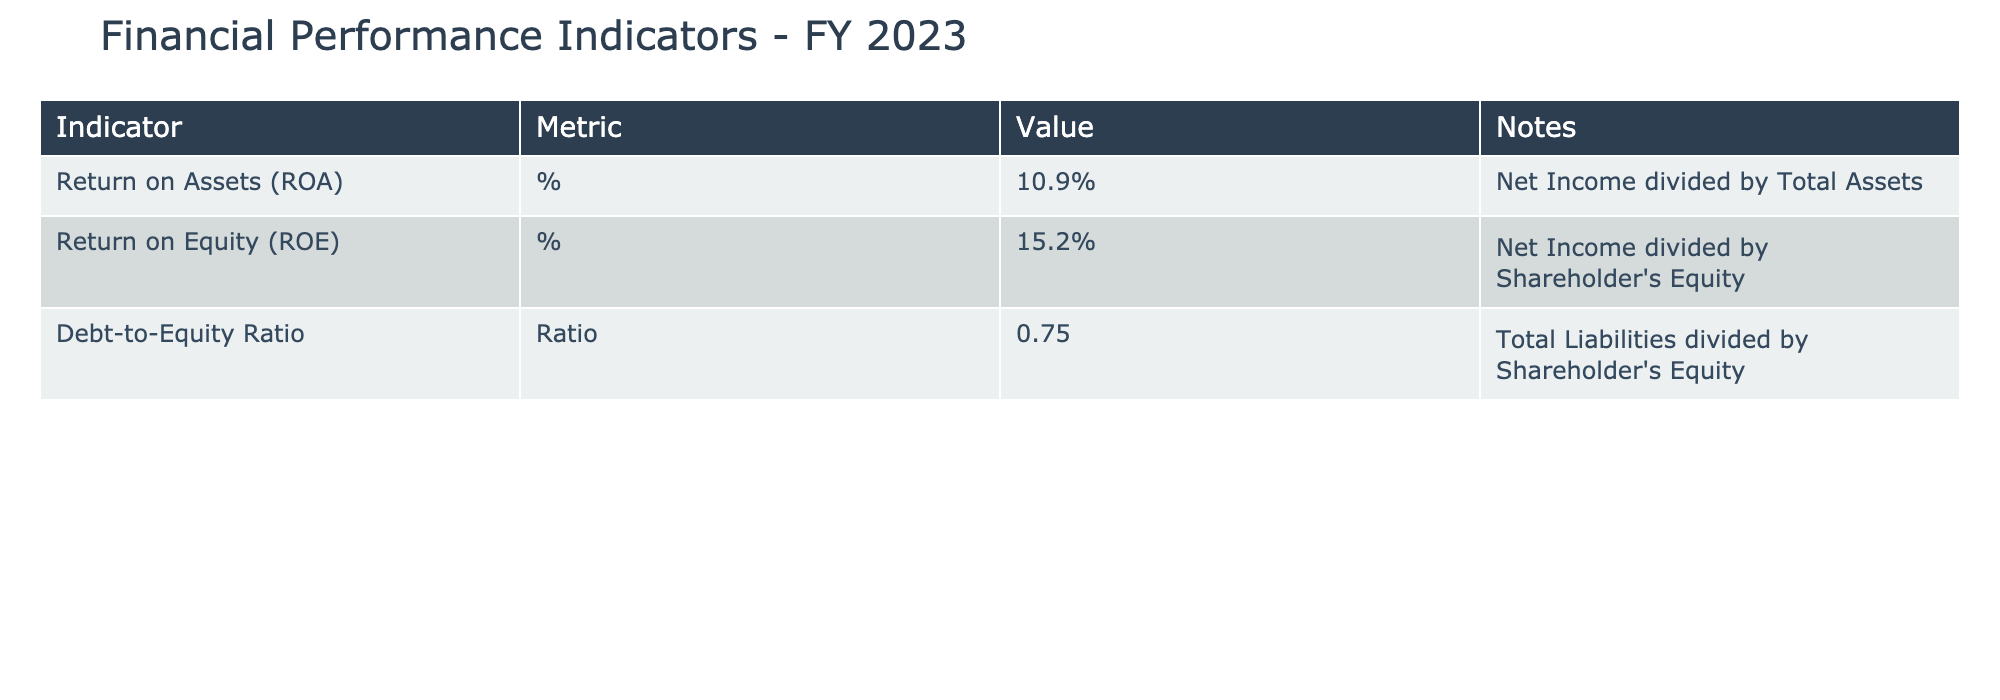What is the value of Return on Assets (ROA)? The table shows that the Return on Assets (ROA) is listed as 10.9%.
Answer: 10.9% What is the Debt-to-Equity Ratio? According to the table, the Debt-to-Equity Ratio is given as 0.75.
Answer: 0.75 Is the Return on Equity (ROE) greater than 15%? The table indicates that the Return on Equity (ROE) is 15.2%, which is indeed greater than 15%.
Answer: Yes What is the average of the Return on Assets (ROA) and Return on Equity (ROE)? The ROA is 10.9% and ROE is 15.2%. To find the average, add these values: 10.9% + 15.2% = 26.1%. Then, divide by 2, which gives 26.1% / 2 = 13.05%.
Answer: 13.05% Is the Debt-to-Equity Ratio less than 1? The table presents the Debt-to-Equity Ratio as 0.75, which is indeed less than 1.
Answer: Yes What is the combined value of ROA and ROE? To find the combined value, add the two indicators together: ROA 10.9% + ROE 15.2% = 26.1%.
Answer: 26.1% What indicator has the highest value, and what is that value? The highest value among the indicators is Return on Equity (ROE), which stands at 15.2%.
Answer: 15.2% If the Total Assets were to increase, how would that affect the return on assets, assuming net income remains constant? If Total Assets increase while Net Income remains unchanged, the Return on Assets (ROA) would decrease, because ROA is calculated as Net Income divided by Total Assets. An increase in the denominator (Total Assets) will result in a lower ROA if the numerator remains the same.
Answer: ROA would decrease How does the company's debt level compare to its equity based on the Debt-to-Equity Ratio? The Debt-to-Equity Ratio of 0.75 indicates that for every dollar of equity, the company has 0.75 dollars in debt. This suggests the company uses relatively less debt compared to its equity.
Answer: Debt is less than equity 